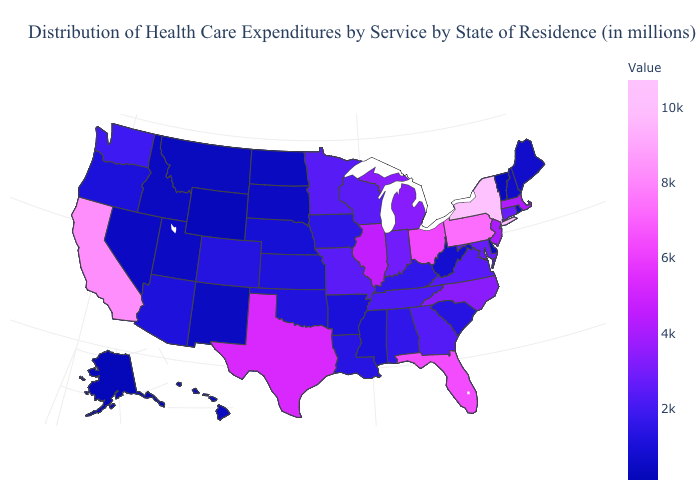Which states have the lowest value in the USA?
Give a very brief answer. Alaska. Among the states that border Iowa , which have the lowest value?
Answer briefly. South Dakota. Among the states that border Oregon , which have the lowest value?
Answer briefly. Idaho. Among the states that border South Dakota , which have the highest value?
Keep it brief. Minnesota. 